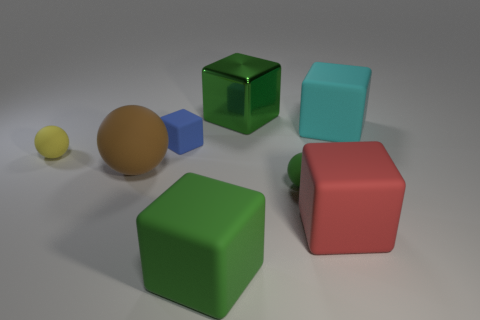Subtract all cyan blocks. How many blocks are left? 4 Subtract all shiny cubes. How many cubes are left? 4 Subtract all brown blocks. Subtract all red cylinders. How many blocks are left? 5 Add 1 large matte blocks. How many objects exist? 9 Subtract all cubes. How many objects are left? 3 Add 5 red blocks. How many red blocks exist? 6 Subtract 0 green cylinders. How many objects are left? 8 Subtract all tiny yellow blocks. Subtract all small objects. How many objects are left? 5 Add 7 green objects. How many green objects are left? 10 